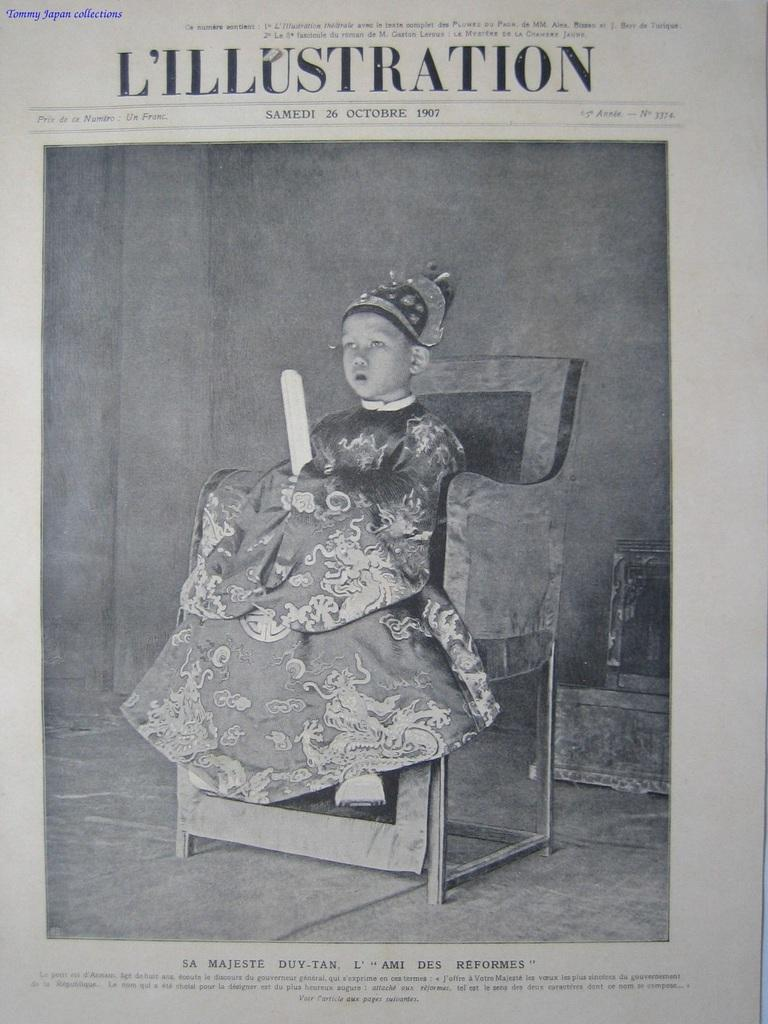What is the main object in the image? There is a paper in the image. What is happening on the paper? A child is sitting in a chair on the paper. Is there any text on the paper? Yes, there is text at the top of the paper. What type of plant is growing on the paper in the image? There is no plant growing on the paper in the image; it only features a child sitting in a chair and text at the top. 